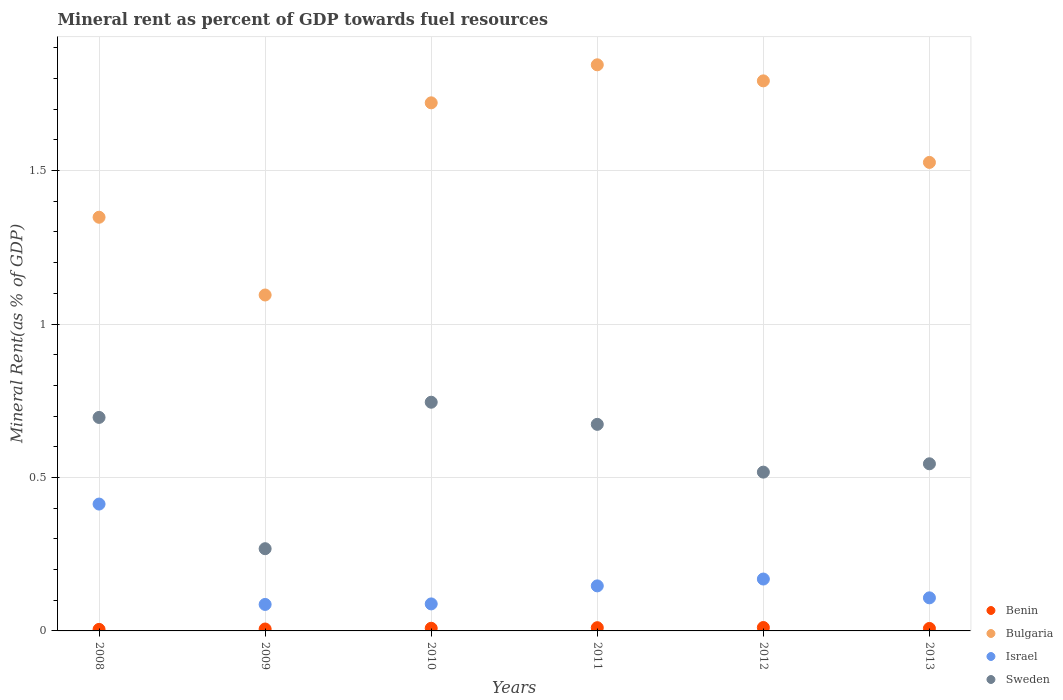How many different coloured dotlines are there?
Offer a very short reply. 4. Is the number of dotlines equal to the number of legend labels?
Your answer should be compact. Yes. What is the mineral rent in Bulgaria in 2009?
Keep it short and to the point. 1.09. Across all years, what is the maximum mineral rent in Bulgaria?
Make the answer very short. 1.84. Across all years, what is the minimum mineral rent in Sweden?
Offer a very short reply. 0.27. What is the total mineral rent in Bulgaria in the graph?
Ensure brevity in your answer.  9.33. What is the difference between the mineral rent in Sweden in 2008 and that in 2010?
Make the answer very short. -0.05. What is the difference between the mineral rent in Benin in 2011 and the mineral rent in Bulgaria in 2012?
Provide a short and direct response. -1.78. What is the average mineral rent in Sweden per year?
Your response must be concise. 0.57. In the year 2011, what is the difference between the mineral rent in Sweden and mineral rent in Benin?
Make the answer very short. 0.66. What is the ratio of the mineral rent in Bulgaria in 2009 to that in 2011?
Give a very brief answer. 0.59. Is the mineral rent in Israel in 2011 less than that in 2012?
Your answer should be very brief. Yes. What is the difference between the highest and the second highest mineral rent in Israel?
Your answer should be compact. 0.24. What is the difference between the highest and the lowest mineral rent in Sweden?
Your answer should be compact. 0.48. In how many years, is the mineral rent in Bulgaria greater than the average mineral rent in Bulgaria taken over all years?
Ensure brevity in your answer.  3. Is it the case that in every year, the sum of the mineral rent in Bulgaria and mineral rent in Sweden  is greater than the sum of mineral rent in Israel and mineral rent in Benin?
Offer a very short reply. Yes. Is it the case that in every year, the sum of the mineral rent in Benin and mineral rent in Israel  is greater than the mineral rent in Bulgaria?
Your answer should be compact. No. Does the mineral rent in Israel monotonically increase over the years?
Your answer should be very brief. No. How many dotlines are there?
Your answer should be very brief. 4. Are the values on the major ticks of Y-axis written in scientific E-notation?
Make the answer very short. No. Does the graph contain any zero values?
Ensure brevity in your answer.  No. Does the graph contain grids?
Ensure brevity in your answer.  Yes. How many legend labels are there?
Your answer should be very brief. 4. What is the title of the graph?
Give a very brief answer. Mineral rent as percent of GDP towards fuel resources. Does "Sudan" appear as one of the legend labels in the graph?
Offer a terse response. No. What is the label or title of the X-axis?
Ensure brevity in your answer.  Years. What is the label or title of the Y-axis?
Offer a terse response. Mineral Rent(as % of GDP). What is the Mineral Rent(as % of GDP) of Benin in 2008?
Offer a terse response. 0. What is the Mineral Rent(as % of GDP) of Bulgaria in 2008?
Give a very brief answer. 1.35. What is the Mineral Rent(as % of GDP) of Israel in 2008?
Provide a succinct answer. 0.41. What is the Mineral Rent(as % of GDP) of Sweden in 2008?
Your answer should be very brief. 0.7. What is the Mineral Rent(as % of GDP) of Benin in 2009?
Offer a terse response. 0.01. What is the Mineral Rent(as % of GDP) of Bulgaria in 2009?
Your answer should be very brief. 1.09. What is the Mineral Rent(as % of GDP) of Israel in 2009?
Your response must be concise. 0.09. What is the Mineral Rent(as % of GDP) in Sweden in 2009?
Keep it short and to the point. 0.27. What is the Mineral Rent(as % of GDP) in Benin in 2010?
Your answer should be very brief. 0.01. What is the Mineral Rent(as % of GDP) in Bulgaria in 2010?
Your answer should be compact. 1.72. What is the Mineral Rent(as % of GDP) of Israel in 2010?
Keep it short and to the point. 0.09. What is the Mineral Rent(as % of GDP) in Sweden in 2010?
Offer a terse response. 0.75. What is the Mineral Rent(as % of GDP) in Benin in 2011?
Keep it short and to the point. 0.01. What is the Mineral Rent(as % of GDP) of Bulgaria in 2011?
Give a very brief answer. 1.84. What is the Mineral Rent(as % of GDP) in Israel in 2011?
Keep it short and to the point. 0.15. What is the Mineral Rent(as % of GDP) of Sweden in 2011?
Offer a terse response. 0.67. What is the Mineral Rent(as % of GDP) in Benin in 2012?
Give a very brief answer. 0.01. What is the Mineral Rent(as % of GDP) of Bulgaria in 2012?
Your answer should be compact. 1.79. What is the Mineral Rent(as % of GDP) of Israel in 2012?
Offer a terse response. 0.17. What is the Mineral Rent(as % of GDP) in Sweden in 2012?
Give a very brief answer. 0.52. What is the Mineral Rent(as % of GDP) in Benin in 2013?
Your answer should be compact. 0.01. What is the Mineral Rent(as % of GDP) in Bulgaria in 2013?
Make the answer very short. 1.53. What is the Mineral Rent(as % of GDP) of Israel in 2013?
Offer a very short reply. 0.11. What is the Mineral Rent(as % of GDP) in Sweden in 2013?
Offer a terse response. 0.54. Across all years, what is the maximum Mineral Rent(as % of GDP) in Benin?
Your answer should be compact. 0.01. Across all years, what is the maximum Mineral Rent(as % of GDP) of Bulgaria?
Provide a succinct answer. 1.84. Across all years, what is the maximum Mineral Rent(as % of GDP) in Israel?
Provide a succinct answer. 0.41. Across all years, what is the maximum Mineral Rent(as % of GDP) in Sweden?
Make the answer very short. 0.75. Across all years, what is the minimum Mineral Rent(as % of GDP) of Benin?
Keep it short and to the point. 0. Across all years, what is the minimum Mineral Rent(as % of GDP) of Bulgaria?
Provide a succinct answer. 1.09. Across all years, what is the minimum Mineral Rent(as % of GDP) of Israel?
Provide a succinct answer. 0.09. Across all years, what is the minimum Mineral Rent(as % of GDP) in Sweden?
Provide a short and direct response. 0.27. What is the total Mineral Rent(as % of GDP) of Benin in the graph?
Your answer should be very brief. 0.05. What is the total Mineral Rent(as % of GDP) in Bulgaria in the graph?
Your answer should be compact. 9.33. What is the total Mineral Rent(as % of GDP) of Israel in the graph?
Your answer should be compact. 1.01. What is the total Mineral Rent(as % of GDP) in Sweden in the graph?
Make the answer very short. 3.44. What is the difference between the Mineral Rent(as % of GDP) of Benin in 2008 and that in 2009?
Offer a very short reply. -0. What is the difference between the Mineral Rent(as % of GDP) of Bulgaria in 2008 and that in 2009?
Ensure brevity in your answer.  0.25. What is the difference between the Mineral Rent(as % of GDP) of Israel in 2008 and that in 2009?
Ensure brevity in your answer.  0.33. What is the difference between the Mineral Rent(as % of GDP) in Sweden in 2008 and that in 2009?
Your response must be concise. 0.43. What is the difference between the Mineral Rent(as % of GDP) of Benin in 2008 and that in 2010?
Provide a short and direct response. -0. What is the difference between the Mineral Rent(as % of GDP) of Bulgaria in 2008 and that in 2010?
Provide a short and direct response. -0.37. What is the difference between the Mineral Rent(as % of GDP) in Israel in 2008 and that in 2010?
Keep it short and to the point. 0.33. What is the difference between the Mineral Rent(as % of GDP) in Sweden in 2008 and that in 2010?
Provide a succinct answer. -0.05. What is the difference between the Mineral Rent(as % of GDP) in Benin in 2008 and that in 2011?
Your response must be concise. -0.01. What is the difference between the Mineral Rent(as % of GDP) of Bulgaria in 2008 and that in 2011?
Your answer should be very brief. -0.5. What is the difference between the Mineral Rent(as % of GDP) of Israel in 2008 and that in 2011?
Your answer should be very brief. 0.27. What is the difference between the Mineral Rent(as % of GDP) of Sweden in 2008 and that in 2011?
Your response must be concise. 0.02. What is the difference between the Mineral Rent(as % of GDP) in Benin in 2008 and that in 2012?
Offer a very short reply. -0.01. What is the difference between the Mineral Rent(as % of GDP) of Bulgaria in 2008 and that in 2012?
Give a very brief answer. -0.44. What is the difference between the Mineral Rent(as % of GDP) in Israel in 2008 and that in 2012?
Your response must be concise. 0.24. What is the difference between the Mineral Rent(as % of GDP) of Sweden in 2008 and that in 2012?
Ensure brevity in your answer.  0.18. What is the difference between the Mineral Rent(as % of GDP) of Benin in 2008 and that in 2013?
Provide a short and direct response. -0. What is the difference between the Mineral Rent(as % of GDP) of Bulgaria in 2008 and that in 2013?
Make the answer very short. -0.18. What is the difference between the Mineral Rent(as % of GDP) in Israel in 2008 and that in 2013?
Offer a terse response. 0.31. What is the difference between the Mineral Rent(as % of GDP) of Sweden in 2008 and that in 2013?
Ensure brevity in your answer.  0.15. What is the difference between the Mineral Rent(as % of GDP) in Benin in 2009 and that in 2010?
Your answer should be compact. -0. What is the difference between the Mineral Rent(as % of GDP) of Bulgaria in 2009 and that in 2010?
Your response must be concise. -0.63. What is the difference between the Mineral Rent(as % of GDP) in Israel in 2009 and that in 2010?
Your answer should be compact. -0. What is the difference between the Mineral Rent(as % of GDP) in Sweden in 2009 and that in 2010?
Your answer should be very brief. -0.48. What is the difference between the Mineral Rent(as % of GDP) in Benin in 2009 and that in 2011?
Offer a terse response. -0. What is the difference between the Mineral Rent(as % of GDP) in Bulgaria in 2009 and that in 2011?
Offer a terse response. -0.75. What is the difference between the Mineral Rent(as % of GDP) in Israel in 2009 and that in 2011?
Provide a short and direct response. -0.06. What is the difference between the Mineral Rent(as % of GDP) of Sweden in 2009 and that in 2011?
Provide a succinct answer. -0.41. What is the difference between the Mineral Rent(as % of GDP) in Benin in 2009 and that in 2012?
Ensure brevity in your answer.  -0. What is the difference between the Mineral Rent(as % of GDP) in Bulgaria in 2009 and that in 2012?
Your answer should be compact. -0.7. What is the difference between the Mineral Rent(as % of GDP) in Israel in 2009 and that in 2012?
Your answer should be compact. -0.08. What is the difference between the Mineral Rent(as % of GDP) of Sweden in 2009 and that in 2012?
Offer a very short reply. -0.25. What is the difference between the Mineral Rent(as % of GDP) in Benin in 2009 and that in 2013?
Keep it short and to the point. -0. What is the difference between the Mineral Rent(as % of GDP) in Bulgaria in 2009 and that in 2013?
Give a very brief answer. -0.43. What is the difference between the Mineral Rent(as % of GDP) in Israel in 2009 and that in 2013?
Offer a very short reply. -0.02. What is the difference between the Mineral Rent(as % of GDP) in Sweden in 2009 and that in 2013?
Offer a terse response. -0.28. What is the difference between the Mineral Rent(as % of GDP) in Benin in 2010 and that in 2011?
Your answer should be very brief. -0. What is the difference between the Mineral Rent(as % of GDP) in Bulgaria in 2010 and that in 2011?
Give a very brief answer. -0.12. What is the difference between the Mineral Rent(as % of GDP) of Israel in 2010 and that in 2011?
Offer a terse response. -0.06. What is the difference between the Mineral Rent(as % of GDP) in Sweden in 2010 and that in 2011?
Keep it short and to the point. 0.07. What is the difference between the Mineral Rent(as % of GDP) of Benin in 2010 and that in 2012?
Provide a succinct answer. -0. What is the difference between the Mineral Rent(as % of GDP) of Bulgaria in 2010 and that in 2012?
Provide a short and direct response. -0.07. What is the difference between the Mineral Rent(as % of GDP) of Israel in 2010 and that in 2012?
Offer a very short reply. -0.08. What is the difference between the Mineral Rent(as % of GDP) of Sweden in 2010 and that in 2012?
Offer a very short reply. 0.23. What is the difference between the Mineral Rent(as % of GDP) in Bulgaria in 2010 and that in 2013?
Your answer should be very brief. 0.19. What is the difference between the Mineral Rent(as % of GDP) in Israel in 2010 and that in 2013?
Provide a succinct answer. -0.02. What is the difference between the Mineral Rent(as % of GDP) of Sweden in 2010 and that in 2013?
Keep it short and to the point. 0.2. What is the difference between the Mineral Rent(as % of GDP) of Benin in 2011 and that in 2012?
Ensure brevity in your answer.  -0. What is the difference between the Mineral Rent(as % of GDP) in Bulgaria in 2011 and that in 2012?
Offer a terse response. 0.05. What is the difference between the Mineral Rent(as % of GDP) in Israel in 2011 and that in 2012?
Keep it short and to the point. -0.02. What is the difference between the Mineral Rent(as % of GDP) of Sweden in 2011 and that in 2012?
Provide a short and direct response. 0.16. What is the difference between the Mineral Rent(as % of GDP) in Benin in 2011 and that in 2013?
Offer a very short reply. 0. What is the difference between the Mineral Rent(as % of GDP) of Bulgaria in 2011 and that in 2013?
Your answer should be compact. 0.32. What is the difference between the Mineral Rent(as % of GDP) in Israel in 2011 and that in 2013?
Your answer should be compact. 0.04. What is the difference between the Mineral Rent(as % of GDP) in Sweden in 2011 and that in 2013?
Keep it short and to the point. 0.13. What is the difference between the Mineral Rent(as % of GDP) in Benin in 2012 and that in 2013?
Provide a short and direct response. 0. What is the difference between the Mineral Rent(as % of GDP) of Bulgaria in 2012 and that in 2013?
Keep it short and to the point. 0.27. What is the difference between the Mineral Rent(as % of GDP) of Israel in 2012 and that in 2013?
Your answer should be compact. 0.06. What is the difference between the Mineral Rent(as % of GDP) of Sweden in 2012 and that in 2013?
Your response must be concise. -0.03. What is the difference between the Mineral Rent(as % of GDP) in Benin in 2008 and the Mineral Rent(as % of GDP) in Bulgaria in 2009?
Offer a terse response. -1.09. What is the difference between the Mineral Rent(as % of GDP) in Benin in 2008 and the Mineral Rent(as % of GDP) in Israel in 2009?
Your answer should be very brief. -0.08. What is the difference between the Mineral Rent(as % of GDP) in Benin in 2008 and the Mineral Rent(as % of GDP) in Sweden in 2009?
Ensure brevity in your answer.  -0.26. What is the difference between the Mineral Rent(as % of GDP) in Bulgaria in 2008 and the Mineral Rent(as % of GDP) in Israel in 2009?
Your answer should be compact. 1.26. What is the difference between the Mineral Rent(as % of GDP) in Israel in 2008 and the Mineral Rent(as % of GDP) in Sweden in 2009?
Ensure brevity in your answer.  0.15. What is the difference between the Mineral Rent(as % of GDP) of Benin in 2008 and the Mineral Rent(as % of GDP) of Bulgaria in 2010?
Your answer should be very brief. -1.72. What is the difference between the Mineral Rent(as % of GDP) of Benin in 2008 and the Mineral Rent(as % of GDP) of Israel in 2010?
Your response must be concise. -0.08. What is the difference between the Mineral Rent(as % of GDP) in Benin in 2008 and the Mineral Rent(as % of GDP) in Sweden in 2010?
Your answer should be compact. -0.74. What is the difference between the Mineral Rent(as % of GDP) in Bulgaria in 2008 and the Mineral Rent(as % of GDP) in Israel in 2010?
Keep it short and to the point. 1.26. What is the difference between the Mineral Rent(as % of GDP) of Bulgaria in 2008 and the Mineral Rent(as % of GDP) of Sweden in 2010?
Provide a short and direct response. 0.6. What is the difference between the Mineral Rent(as % of GDP) in Israel in 2008 and the Mineral Rent(as % of GDP) in Sweden in 2010?
Ensure brevity in your answer.  -0.33. What is the difference between the Mineral Rent(as % of GDP) in Benin in 2008 and the Mineral Rent(as % of GDP) in Bulgaria in 2011?
Offer a very short reply. -1.84. What is the difference between the Mineral Rent(as % of GDP) in Benin in 2008 and the Mineral Rent(as % of GDP) in Israel in 2011?
Provide a short and direct response. -0.14. What is the difference between the Mineral Rent(as % of GDP) of Benin in 2008 and the Mineral Rent(as % of GDP) of Sweden in 2011?
Provide a short and direct response. -0.67. What is the difference between the Mineral Rent(as % of GDP) of Bulgaria in 2008 and the Mineral Rent(as % of GDP) of Israel in 2011?
Offer a very short reply. 1.2. What is the difference between the Mineral Rent(as % of GDP) of Bulgaria in 2008 and the Mineral Rent(as % of GDP) of Sweden in 2011?
Your answer should be compact. 0.67. What is the difference between the Mineral Rent(as % of GDP) of Israel in 2008 and the Mineral Rent(as % of GDP) of Sweden in 2011?
Offer a terse response. -0.26. What is the difference between the Mineral Rent(as % of GDP) of Benin in 2008 and the Mineral Rent(as % of GDP) of Bulgaria in 2012?
Your response must be concise. -1.79. What is the difference between the Mineral Rent(as % of GDP) of Benin in 2008 and the Mineral Rent(as % of GDP) of Israel in 2012?
Your answer should be very brief. -0.16. What is the difference between the Mineral Rent(as % of GDP) of Benin in 2008 and the Mineral Rent(as % of GDP) of Sweden in 2012?
Keep it short and to the point. -0.51. What is the difference between the Mineral Rent(as % of GDP) in Bulgaria in 2008 and the Mineral Rent(as % of GDP) in Israel in 2012?
Provide a short and direct response. 1.18. What is the difference between the Mineral Rent(as % of GDP) of Bulgaria in 2008 and the Mineral Rent(as % of GDP) of Sweden in 2012?
Ensure brevity in your answer.  0.83. What is the difference between the Mineral Rent(as % of GDP) of Israel in 2008 and the Mineral Rent(as % of GDP) of Sweden in 2012?
Provide a short and direct response. -0.1. What is the difference between the Mineral Rent(as % of GDP) in Benin in 2008 and the Mineral Rent(as % of GDP) in Bulgaria in 2013?
Your answer should be compact. -1.52. What is the difference between the Mineral Rent(as % of GDP) of Benin in 2008 and the Mineral Rent(as % of GDP) of Israel in 2013?
Offer a very short reply. -0.1. What is the difference between the Mineral Rent(as % of GDP) in Benin in 2008 and the Mineral Rent(as % of GDP) in Sweden in 2013?
Keep it short and to the point. -0.54. What is the difference between the Mineral Rent(as % of GDP) in Bulgaria in 2008 and the Mineral Rent(as % of GDP) in Israel in 2013?
Your answer should be compact. 1.24. What is the difference between the Mineral Rent(as % of GDP) in Bulgaria in 2008 and the Mineral Rent(as % of GDP) in Sweden in 2013?
Offer a terse response. 0.8. What is the difference between the Mineral Rent(as % of GDP) in Israel in 2008 and the Mineral Rent(as % of GDP) in Sweden in 2013?
Provide a succinct answer. -0.13. What is the difference between the Mineral Rent(as % of GDP) in Benin in 2009 and the Mineral Rent(as % of GDP) in Bulgaria in 2010?
Provide a succinct answer. -1.71. What is the difference between the Mineral Rent(as % of GDP) of Benin in 2009 and the Mineral Rent(as % of GDP) of Israel in 2010?
Offer a very short reply. -0.08. What is the difference between the Mineral Rent(as % of GDP) of Benin in 2009 and the Mineral Rent(as % of GDP) of Sweden in 2010?
Offer a very short reply. -0.74. What is the difference between the Mineral Rent(as % of GDP) in Bulgaria in 2009 and the Mineral Rent(as % of GDP) in Israel in 2010?
Offer a terse response. 1.01. What is the difference between the Mineral Rent(as % of GDP) of Bulgaria in 2009 and the Mineral Rent(as % of GDP) of Sweden in 2010?
Make the answer very short. 0.35. What is the difference between the Mineral Rent(as % of GDP) of Israel in 2009 and the Mineral Rent(as % of GDP) of Sweden in 2010?
Your response must be concise. -0.66. What is the difference between the Mineral Rent(as % of GDP) of Benin in 2009 and the Mineral Rent(as % of GDP) of Bulgaria in 2011?
Offer a terse response. -1.84. What is the difference between the Mineral Rent(as % of GDP) of Benin in 2009 and the Mineral Rent(as % of GDP) of Israel in 2011?
Provide a short and direct response. -0.14. What is the difference between the Mineral Rent(as % of GDP) of Benin in 2009 and the Mineral Rent(as % of GDP) of Sweden in 2011?
Provide a succinct answer. -0.67. What is the difference between the Mineral Rent(as % of GDP) in Bulgaria in 2009 and the Mineral Rent(as % of GDP) in Israel in 2011?
Provide a succinct answer. 0.95. What is the difference between the Mineral Rent(as % of GDP) in Bulgaria in 2009 and the Mineral Rent(as % of GDP) in Sweden in 2011?
Offer a very short reply. 0.42. What is the difference between the Mineral Rent(as % of GDP) in Israel in 2009 and the Mineral Rent(as % of GDP) in Sweden in 2011?
Ensure brevity in your answer.  -0.59. What is the difference between the Mineral Rent(as % of GDP) in Benin in 2009 and the Mineral Rent(as % of GDP) in Bulgaria in 2012?
Give a very brief answer. -1.79. What is the difference between the Mineral Rent(as % of GDP) in Benin in 2009 and the Mineral Rent(as % of GDP) in Israel in 2012?
Give a very brief answer. -0.16. What is the difference between the Mineral Rent(as % of GDP) in Benin in 2009 and the Mineral Rent(as % of GDP) in Sweden in 2012?
Make the answer very short. -0.51. What is the difference between the Mineral Rent(as % of GDP) in Bulgaria in 2009 and the Mineral Rent(as % of GDP) in Israel in 2012?
Provide a short and direct response. 0.93. What is the difference between the Mineral Rent(as % of GDP) of Bulgaria in 2009 and the Mineral Rent(as % of GDP) of Sweden in 2012?
Give a very brief answer. 0.58. What is the difference between the Mineral Rent(as % of GDP) in Israel in 2009 and the Mineral Rent(as % of GDP) in Sweden in 2012?
Provide a short and direct response. -0.43. What is the difference between the Mineral Rent(as % of GDP) of Benin in 2009 and the Mineral Rent(as % of GDP) of Bulgaria in 2013?
Offer a terse response. -1.52. What is the difference between the Mineral Rent(as % of GDP) of Benin in 2009 and the Mineral Rent(as % of GDP) of Israel in 2013?
Offer a very short reply. -0.1. What is the difference between the Mineral Rent(as % of GDP) of Benin in 2009 and the Mineral Rent(as % of GDP) of Sweden in 2013?
Keep it short and to the point. -0.54. What is the difference between the Mineral Rent(as % of GDP) in Bulgaria in 2009 and the Mineral Rent(as % of GDP) in Israel in 2013?
Provide a short and direct response. 0.99. What is the difference between the Mineral Rent(as % of GDP) of Bulgaria in 2009 and the Mineral Rent(as % of GDP) of Sweden in 2013?
Your answer should be compact. 0.55. What is the difference between the Mineral Rent(as % of GDP) of Israel in 2009 and the Mineral Rent(as % of GDP) of Sweden in 2013?
Make the answer very short. -0.46. What is the difference between the Mineral Rent(as % of GDP) in Benin in 2010 and the Mineral Rent(as % of GDP) in Bulgaria in 2011?
Make the answer very short. -1.84. What is the difference between the Mineral Rent(as % of GDP) of Benin in 2010 and the Mineral Rent(as % of GDP) of Israel in 2011?
Keep it short and to the point. -0.14. What is the difference between the Mineral Rent(as % of GDP) in Benin in 2010 and the Mineral Rent(as % of GDP) in Sweden in 2011?
Give a very brief answer. -0.66. What is the difference between the Mineral Rent(as % of GDP) of Bulgaria in 2010 and the Mineral Rent(as % of GDP) of Israel in 2011?
Your response must be concise. 1.57. What is the difference between the Mineral Rent(as % of GDP) of Bulgaria in 2010 and the Mineral Rent(as % of GDP) of Sweden in 2011?
Make the answer very short. 1.05. What is the difference between the Mineral Rent(as % of GDP) of Israel in 2010 and the Mineral Rent(as % of GDP) of Sweden in 2011?
Make the answer very short. -0.59. What is the difference between the Mineral Rent(as % of GDP) in Benin in 2010 and the Mineral Rent(as % of GDP) in Bulgaria in 2012?
Ensure brevity in your answer.  -1.78. What is the difference between the Mineral Rent(as % of GDP) of Benin in 2010 and the Mineral Rent(as % of GDP) of Israel in 2012?
Provide a short and direct response. -0.16. What is the difference between the Mineral Rent(as % of GDP) in Benin in 2010 and the Mineral Rent(as % of GDP) in Sweden in 2012?
Keep it short and to the point. -0.51. What is the difference between the Mineral Rent(as % of GDP) in Bulgaria in 2010 and the Mineral Rent(as % of GDP) in Israel in 2012?
Ensure brevity in your answer.  1.55. What is the difference between the Mineral Rent(as % of GDP) of Bulgaria in 2010 and the Mineral Rent(as % of GDP) of Sweden in 2012?
Offer a very short reply. 1.2. What is the difference between the Mineral Rent(as % of GDP) in Israel in 2010 and the Mineral Rent(as % of GDP) in Sweden in 2012?
Offer a terse response. -0.43. What is the difference between the Mineral Rent(as % of GDP) of Benin in 2010 and the Mineral Rent(as % of GDP) of Bulgaria in 2013?
Offer a very short reply. -1.52. What is the difference between the Mineral Rent(as % of GDP) of Benin in 2010 and the Mineral Rent(as % of GDP) of Israel in 2013?
Provide a short and direct response. -0.1. What is the difference between the Mineral Rent(as % of GDP) in Benin in 2010 and the Mineral Rent(as % of GDP) in Sweden in 2013?
Ensure brevity in your answer.  -0.54. What is the difference between the Mineral Rent(as % of GDP) in Bulgaria in 2010 and the Mineral Rent(as % of GDP) in Israel in 2013?
Make the answer very short. 1.61. What is the difference between the Mineral Rent(as % of GDP) of Bulgaria in 2010 and the Mineral Rent(as % of GDP) of Sweden in 2013?
Provide a short and direct response. 1.18. What is the difference between the Mineral Rent(as % of GDP) of Israel in 2010 and the Mineral Rent(as % of GDP) of Sweden in 2013?
Your answer should be very brief. -0.46. What is the difference between the Mineral Rent(as % of GDP) in Benin in 2011 and the Mineral Rent(as % of GDP) in Bulgaria in 2012?
Your answer should be compact. -1.78. What is the difference between the Mineral Rent(as % of GDP) of Benin in 2011 and the Mineral Rent(as % of GDP) of Israel in 2012?
Your response must be concise. -0.16. What is the difference between the Mineral Rent(as % of GDP) in Benin in 2011 and the Mineral Rent(as % of GDP) in Sweden in 2012?
Make the answer very short. -0.51. What is the difference between the Mineral Rent(as % of GDP) in Bulgaria in 2011 and the Mineral Rent(as % of GDP) in Israel in 2012?
Keep it short and to the point. 1.68. What is the difference between the Mineral Rent(as % of GDP) of Bulgaria in 2011 and the Mineral Rent(as % of GDP) of Sweden in 2012?
Offer a very short reply. 1.33. What is the difference between the Mineral Rent(as % of GDP) in Israel in 2011 and the Mineral Rent(as % of GDP) in Sweden in 2012?
Offer a terse response. -0.37. What is the difference between the Mineral Rent(as % of GDP) of Benin in 2011 and the Mineral Rent(as % of GDP) of Bulgaria in 2013?
Your answer should be compact. -1.52. What is the difference between the Mineral Rent(as % of GDP) of Benin in 2011 and the Mineral Rent(as % of GDP) of Israel in 2013?
Your answer should be very brief. -0.1. What is the difference between the Mineral Rent(as % of GDP) of Benin in 2011 and the Mineral Rent(as % of GDP) of Sweden in 2013?
Give a very brief answer. -0.53. What is the difference between the Mineral Rent(as % of GDP) in Bulgaria in 2011 and the Mineral Rent(as % of GDP) in Israel in 2013?
Offer a very short reply. 1.74. What is the difference between the Mineral Rent(as % of GDP) in Bulgaria in 2011 and the Mineral Rent(as % of GDP) in Sweden in 2013?
Provide a succinct answer. 1.3. What is the difference between the Mineral Rent(as % of GDP) of Israel in 2011 and the Mineral Rent(as % of GDP) of Sweden in 2013?
Make the answer very short. -0.4. What is the difference between the Mineral Rent(as % of GDP) in Benin in 2012 and the Mineral Rent(as % of GDP) in Bulgaria in 2013?
Offer a terse response. -1.52. What is the difference between the Mineral Rent(as % of GDP) in Benin in 2012 and the Mineral Rent(as % of GDP) in Israel in 2013?
Your answer should be compact. -0.1. What is the difference between the Mineral Rent(as % of GDP) in Benin in 2012 and the Mineral Rent(as % of GDP) in Sweden in 2013?
Give a very brief answer. -0.53. What is the difference between the Mineral Rent(as % of GDP) in Bulgaria in 2012 and the Mineral Rent(as % of GDP) in Israel in 2013?
Give a very brief answer. 1.68. What is the difference between the Mineral Rent(as % of GDP) in Bulgaria in 2012 and the Mineral Rent(as % of GDP) in Sweden in 2013?
Keep it short and to the point. 1.25. What is the difference between the Mineral Rent(as % of GDP) in Israel in 2012 and the Mineral Rent(as % of GDP) in Sweden in 2013?
Offer a very short reply. -0.38. What is the average Mineral Rent(as % of GDP) of Benin per year?
Give a very brief answer. 0.01. What is the average Mineral Rent(as % of GDP) in Bulgaria per year?
Offer a very short reply. 1.55. What is the average Mineral Rent(as % of GDP) of Israel per year?
Provide a short and direct response. 0.17. What is the average Mineral Rent(as % of GDP) in Sweden per year?
Your answer should be compact. 0.57. In the year 2008, what is the difference between the Mineral Rent(as % of GDP) in Benin and Mineral Rent(as % of GDP) in Bulgaria?
Make the answer very short. -1.34. In the year 2008, what is the difference between the Mineral Rent(as % of GDP) in Benin and Mineral Rent(as % of GDP) in Israel?
Ensure brevity in your answer.  -0.41. In the year 2008, what is the difference between the Mineral Rent(as % of GDP) in Benin and Mineral Rent(as % of GDP) in Sweden?
Provide a succinct answer. -0.69. In the year 2008, what is the difference between the Mineral Rent(as % of GDP) of Bulgaria and Mineral Rent(as % of GDP) of Israel?
Keep it short and to the point. 0.93. In the year 2008, what is the difference between the Mineral Rent(as % of GDP) in Bulgaria and Mineral Rent(as % of GDP) in Sweden?
Your response must be concise. 0.65. In the year 2008, what is the difference between the Mineral Rent(as % of GDP) of Israel and Mineral Rent(as % of GDP) of Sweden?
Provide a succinct answer. -0.28. In the year 2009, what is the difference between the Mineral Rent(as % of GDP) of Benin and Mineral Rent(as % of GDP) of Bulgaria?
Your answer should be very brief. -1.09. In the year 2009, what is the difference between the Mineral Rent(as % of GDP) of Benin and Mineral Rent(as % of GDP) of Israel?
Provide a short and direct response. -0.08. In the year 2009, what is the difference between the Mineral Rent(as % of GDP) in Benin and Mineral Rent(as % of GDP) in Sweden?
Give a very brief answer. -0.26. In the year 2009, what is the difference between the Mineral Rent(as % of GDP) in Bulgaria and Mineral Rent(as % of GDP) in Israel?
Offer a terse response. 1.01. In the year 2009, what is the difference between the Mineral Rent(as % of GDP) of Bulgaria and Mineral Rent(as % of GDP) of Sweden?
Offer a very short reply. 0.83. In the year 2009, what is the difference between the Mineral Rent(as % of GDP) of Israel and Mineral Rent(as % of GDP) of Sweden?
Your answer should be very brief. -0.18. In the year 2010, what is the difference between the Mineral Rent(as % of GDP) of Benin and Mineral Rent(as % of GDP) of Bulgaria?
Provide a succinct answer. -1.71. In the year 2010, what is the difference between the Mineral Rent(as % of GDP) of Benin and Mineral Rent(as % of GDP) of Israel?
Make the answer very short. -0.08. In the year 2010, what is the difference between the Mineral Rent(as % of GDP) of Benin and Mineral Rent(as % of GDP) of Sweden?
Your response must be concise. -0.74. In the year 2010, what is the difference between the Mineral Rent(as % of GDP) in Bulgaria and Mineral Rent(as % of GDP) in Israel?
Provide a short and direct response. 1.63. In the year 2010, what is the difference between the Mineral Rent(as % of GDP) of Bulgaria and Mineral Rent(as % of GDP) of Sweden?
Offer a terse response. 0.98. In the year 2010, what is the difference between the Mineral Rent(as % of GDP) in Israel and Mineral Rent(as % of GDP) in Sweden?
Provide a short and direct response. -0.66. In the year 2011, what is the difference between the Mineral Rent(as % of GDP) of Benin and Mineral Rent(as % of GDP) of Bulgaria?
Ensure brevity in your answer.  -1.83. In the year 2011, what is the difference between the Mineral Rent(as % of GDP) in Benin and Mineral Rent(as % of GDP) in Israel?
Offer a very short reply. -0.14. In the year 2011, what is the difference between the Mineral Rent(as % of GDP) of Benin and Mineral Rent(as % of GDP) of Sweden?
Offer a terse response. -0.66. In the year 2011, what is the difference between the Mineral Rent(as % of GDP) of Bulgaria and Mineral Rent(as % of GDP) of Israel?
Your response must be concise. 1.7. In the year 2011, what is the difference between the Mineral Rent(as % of GDP) in Bulgaria and Mineral Rent(as % of GDP) in Sweden?
Your response must be concise. 1.17. In the year 2011, what is the difference between the Mineral Rent(as % of GDP) in Israel and Mineral Rent(as % of GDP) in Sweden?
Give a very brief answer. -0.53. In the year 2012, what is the difference between the Mineral Rent(as % of GDP) in Benin and Mineral Rent(as % of GDP) in Bulgaria?
Your answer should be very brief. -1.78. In the year 2012, what is the difference between the Mineral Rent(as % of GDP) in Benin and Mineral Rent(as % of GDP) in Israel?
Offer a terse response. -0.16. In the year 2012, what is the difference between the Mineral Rent(as % of GDP) in Benin and Mineral Rent(as % of GDP) in Sweden?
Make the answer very short. -0.51. In the year 2012, what is the difference between the Mineral Rent(as % of GDP) of Bulgaria and Mineral Rent(as % of GDP) of Israel?
Provide a short and direct response. 1.62. In the year 2012, what is the difference between the Mineral Rent(as % of GDP) of Bulgaria and Mineral Rent(as % of GDP) of Sweden?
Offer a very short reply. 1.27. In the year 2012, what is the difference between the Mineral Rent(as % of GDP) in Israel and Mineral Rent(as % of GDP) in Sweden?
Make the answer very short. -0.35. In the year 2013, what is the difference between the Mineral Rent(as % of GDP) of Benin and Mineral Rent(as % of GDP) of Bulgaria?
Provide a short and direct response. -1.52. In the year 2013, what is the difference between the Mineral Rent(as % of GDP) of Benin and Mineral Rent(as % of GDP) of Israel?
Provide a succinct answer. -0.1. In the year 2013, what is the difference between the Mineral Rent(as % of GDP) of Benin and Mineral Rent(as % of GDP) of Sweden?
Offer a terse response. -0.54. In the year 2013, what is the difference between the Mineral Rent(as % of GDP) of Bulgaria and Mineral Rent(as % of GDP) of Israel?
Offer a terse response. 1.42. In the year 2013, what is the difference between the Mineral Rent(as % of GDP) of Bulgaria and Mineral Rent(as % of GDP) of Sweden?
Keep it short and to the point. 0.98. In the year 2013, what is the difference between the Mineral Rent(as % of GDP) in Israel and Mineral Rent(as % of GDP) in Sweden?
Keep it short and to the point. -0.44. What is the ratio of the Mineral Rent(as % of GDP) in Benin in 2008 to that in 2009?
Provide a succinct answer. 0.8. What is the ratio of the Mineral Rent(as % of GDP) in Bulgaria in 2008 to that in 2009?
Your answer should be very brief. 1.23. What is the ratio of the Mineral Rent(as % of GDP) in Israel in 2008 to that in 2009?
Keep it short and to the point. 4.79. What is the ratio of the Mineral Rent(as % of GDP) of Sweden in 2008 to that in 2009?
Offer a very short reply. 2.6. What is the ratio of the Mineral Rent(as % of GDP) in Benin in 2008 to that in 2010?
Keep it short and to the point. 0.58. What is the ratio of the Mineral Rent(as % of GDP) of Bulgaria in 2008 to that in 2010?
Keep it short and to the point. 0.78. What is the ratio of the Mineral Rent(as % of GDP) of Israel in 2008 to that in 2010?
Provide a short and direct response. 4.7. What is the ratio of the Mineral Rent(as % of GDP) in Sweden in 2008 to that in 2010?
Give a very brief answer. 0.93. What is the ratio of the Mineral Rent(as % of GDP) of Benin in 2008 to that in 2011?
Provide a succinct answer. 0.48. What is the ratio of the Mineral Rent(as % of GDP) of Bulgaria in 2008 to that in 2011?
Offer a very short reply. 0.73. What is the ratio of the Mineral Rent(as % of GDP) in Israel in 2008 to that in 2011?
Provide a succinct answer. 2.82. What is the ratio of the Mineral Rent(as % of GDP) of Sweden in 2008 to that in 2011?
Provide a short and direct response. 1.03. What is the ratio of the Mineral Rent(as % of GDP) of Benin in 2008 to that in 2012?
Offer a very short reply. 0.45. What is the ratio of the Mineral Rent(as % of GDP) in Bulgaria in 2008 to that in 2012?
Provide a short and direct response. 0.75. What is the ratio of the Mineral Rent(as % of GDP) in Israel in 2008 to that in 2012?
Your answer should be very brief. 2.44. What is the ratio of the Mineral Rent(as % of GDP) in Sweden in 2008 to that in 2012?
Provide a succinct answer. 1.34. What is the ratio of the Mineral Rent(as % of GDP) of Benin in 2008 to that in 2013?
Your answer should be compact. 0.62. What is the ratio of the Mineral Rent(as % of GDP) in Bulgaria in 2008 to that in 2013?
Provide a short and direct response. 0.88. What is the ratio of the Mineral Rent(as % of GDP) in Israel in 2008 to that in 2013?
Your answer should be compact. 3.83. What is the ratio of the Mineral Rent(as % of GDP) of Sweden in 2008 to that in 2013?
Offer a terse response. 1.28. What is the ratio of the Mineral Rent(as % of GDP) of Benin in 2009 to that in 2010?
Your answer should be very brief. 0.72. What is the ratio of the Mineral Rent(as % of GDP) of Bulgaria in 2009 to that in 2010?
Provide a short and direct response. 0.64. What is the ratio of the Mineral Rent(as % of GDP) of Israel in 2009 to that in 2010?
Ensure brevity in your answer.  0.98. What is the ratio of the Mineral Rent(as % of GDP) in Sweden in 2009 to that in 2010?
Offer a very short reply. 0.36. What is the ratio of the Mineral Rent(as % of GDP) in Benin in 2009 to that in 2011?
Provide a short and direct response. 0.59. What is the ratio of the Mineral Rent(as % of GDP) of Bulgaria in 2009 to that in 2011?
Your answer should be compact. 0.59. What is the ratio of the Mineral Rent(as % of GDP) of Israel in 2009 to that in 2011?
Offer a terse response. 0.59. What is the ratio of the Mineral Rent(as % of GDP) of Sweden in 2009 to that in 2011?
Keep it short and to the point. 0.4. What is the ratio of the Mineral Rent(as % of GDP) in Benin in 2009 to that in 2012?
Give a very brief answer. 0.56. What is the ratio of the Mineral Rent(as % of GDP) in Bulgaria in 2009 to that in 2012?
Offer a very short reply. 0.61. What is the ratio of the Mineral Rent(as % of GDP) of Israel in 2009 to that in 2012?
Provide a short and direct response. 0.51. What is the ratio of the Mineral Rent(as % of GDP) in Sweden in 2009 to that in 2012?
Give a very brief answer. 0.52. What is the ratio of the Mineral Rent(as % of GDP) of Benin in 2009 to that in 2013?
Give a very brief answer. 0.77. What is the ratio of the Mineral Rent(as % of GDP) in Bulgaria in 2009 to that in 2013?
Provide a short and direct response. 0.72. What is the ratio of the Mineral Rent(as % of GDP) in Israel in 2009 to that in 2013?
Offer a terse response. 0.8. What is the ratio of the Mineral Rent(as % of GDP) in Sweden in 2009 to that in 2013?
Your answer should be compact. 0.49. What is the ratio of the Mineral Rent(as % of GDP) in Benin in 2010 to that in 2011?
Ensure brevity in your answer.  0.82. What is the ratio of the Mineral Rent(as % of GDP) of Bulgaria in 2010 to that in 2011?
Your answer should be very brief. 0.93. What is the ratio of the Mineral Rent(as % of GDP) of Israel in 2010 to that in 2011?
Offer a very short reply. 0.6. What is the ratio of the Mineral Rent(as % of GDP) in Sweden in 2010 to that in 2011?
Provide a succinct answer. 1.11. What is the ratio of the Mineral Rent(as % of GDP) of Benin in 2010 to that in 2012?
Your answer should be very brief. 0.78. What is the ratio of the Mineral Rent(as % of GDP) of Bulgaria in 2010 to that in 2012?
Ensure brevity in your answer.  0.96. What is the ratio of the Mineral Rent(as % of GDP) of Israel in 2010 to that in 2012?
Your answer should be very brief. 0.52. What is the ratio of the Mineral Rent(as % of GDP) in Sweden in 2010 to that in 2012?
Your answer should be compact. 1.44. What is the ratio of the Mineral Rent(as % of GDP) in Benin in 2010 to that in 2013?
Your answer should be very brief. 1.06. What is the ratio of the Mineral Rent(as % of GDP) of Bulgaria in 2010 to that in 2013?
Your answer should be very brief. 1.13. What is the ratio of the Mineral Rent(as % of GDP) in Israel in 2010 to that in 2013?
Make the answer very short. 0.82. What is the ratio of the Mineral Rent(as % of GDP) of Sweden in 2010 to that in 2013?
Provide a succinct answer. 1.37. What is the ratio of the Mineral Rent(as % of GDP) of Benin in 2011 to that in 2012?
Your answer should be very brief. 0.95. What is the ratio of the Mineral Rent(as % of GDP) of Bulgaria in 2011 to that in 2012?
Provide a short and direct response. 1.03. What is the ratio of the Mineral Rent(as % of GDP) in Israel in 2011 to that in 2012?
Give a very brief answer. 0.87. What is the ratio of the Mineral Rent(as % of GDP) in Sweden in 2011 to that in 2012?
Your answer should be very brief. 1.3. What is the ratio of the Mineral Rent(as % of GDP) of Benin in 2011 to that in 2013?
Ensure brevity in your answer.  1.3. What is the ratio of the Mineral Rent(as % of GDP) in Bulgaria in 2011 to that in 2013?
Give a very brief answer. 1.21. What is the ratio of the Mineral Rent(as % of GDP) of Israel in 2011 to that in 2013?
Provide a short and direct response. 1.36. What is the ratio of the Mineral Rent(as % of GDP) of Sweden in 2011 to that in 2013?
Provide a short and direct response. 1.24. What is the ratio of the Mineral Rent(as % of GDP) of Benin in 2012 to that in 2013?
Ensure brevity in your answer.  1.37. What is the ratio of the Mineral Rent(as % of GDP) in Bulgaria in 2012 to that in 2013?
Provide a succinct answer. 1.17. What is the ratio of the Mineral Rent(as % of GDP) in Israel in 2012 to that in 2013?
Provide a succinct answer. 1.57. What is the ratio of the Mineral Rent(as % of GDP) in Sweden in 2012 to that in 2013?
Your answer should be very brief. 0.95. What is the difference between the highest and the second highest Mineral Rent(as % of GDP) in Bulgaria?
Make the answer very short. 0.05. What is the difference between the highest and the second highest Mineral Rent(as % of GDP) in Israel?
Offer a terse response. 0.24. What is the difference between the highest and the second highest Mineral Rent(as % of GDP) of Sweden?
Provide a short and direct response. 0.05. What is the difference between the highest and the lowest Mineral Rent(as % of GDP) of Benin?
Offer a very short reply. 0.01. What is the difference between the highest and the lowest Mineral Rent(as % of GDP) of Israel?
Your answer should be very brief. 0.33. What is the difference between the highest and the lowest Mineral Rent(as % of GDP) of Sweden?
Your response must be concise. 0.48. 